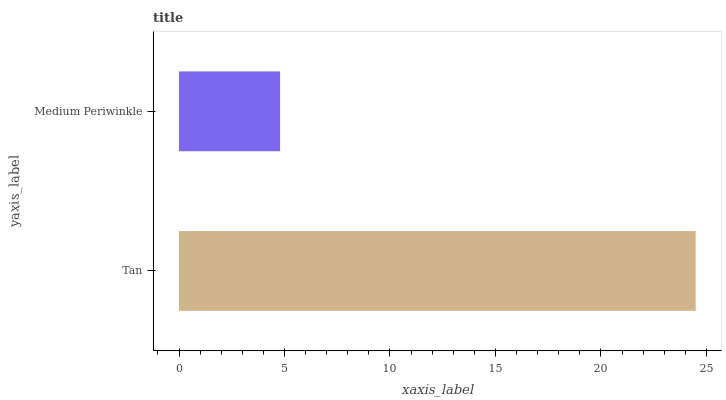Is Medium Periwinkle the minimum?
Answer yes or no. Yes. Is Tan the maximum?
Answer yes or no. Yes. Is Medium Periwinkle the maximum?
Answer yes or no. No. Is Tan greater than Medium Periwinkle?
Answer yes or no. Yes. Is Medium Periwinkle less than Tan?
Answer yes or no. Yes. Is Medium Periwinkle greater than Tan?
Answer yes or no. No. Is Tan less than Medium Periwinkle?
Answer yes or no. No. Is Tan the high median?
Answer yes or no. Yes. Is Medium Periwinkle the low median?
Answer yes or no. Yes. Is Medium Periwinkle the high median?
Answer yes or no. No. Is Tan the low median?
Answer yes or no. No. 